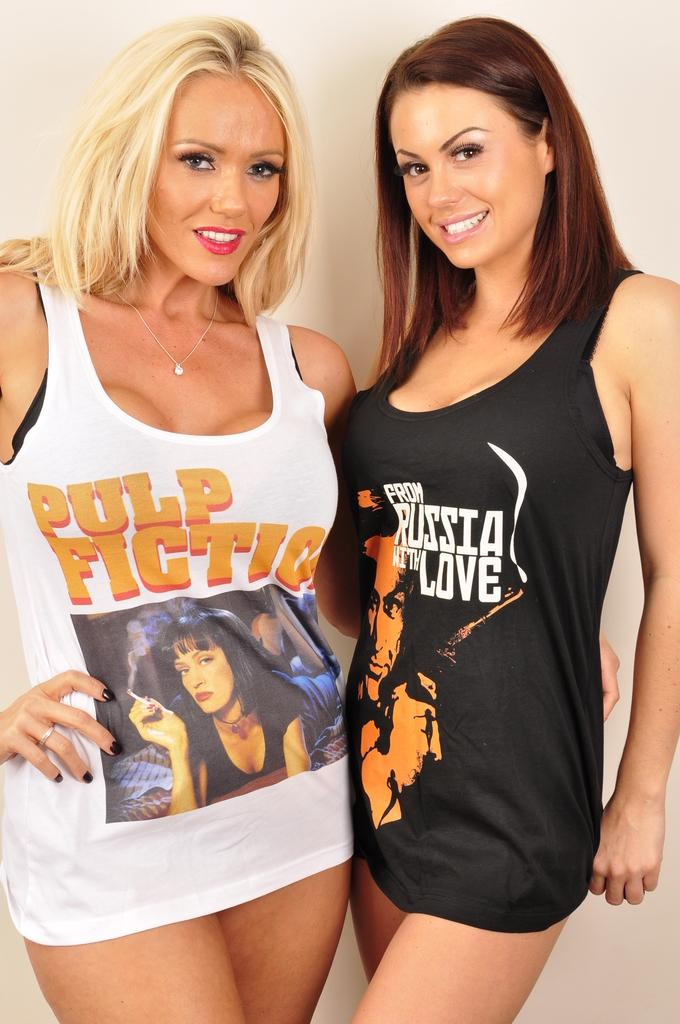<image>
Provide a brief description of the given image. Two women are wearing shirts that say Pulp Fiction and From Russia with Love. 